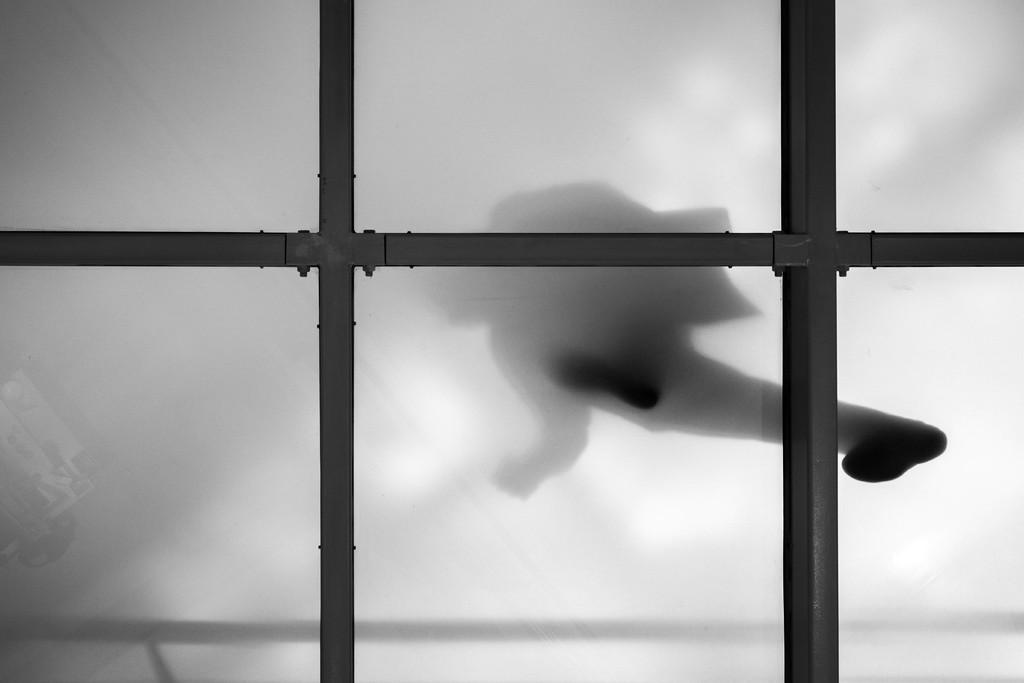What can be seen in the foreground of the image? There is a glass window with a fence in the image. What is happening in the background of the image? There is a person walking in the background of the image. What color is the background of the image? The background of the image is white. Where is the bottle of humor located in the image? There is no bottle of humor present in the image. Is there a stage visible in the image? There is no stage visible in the image. 